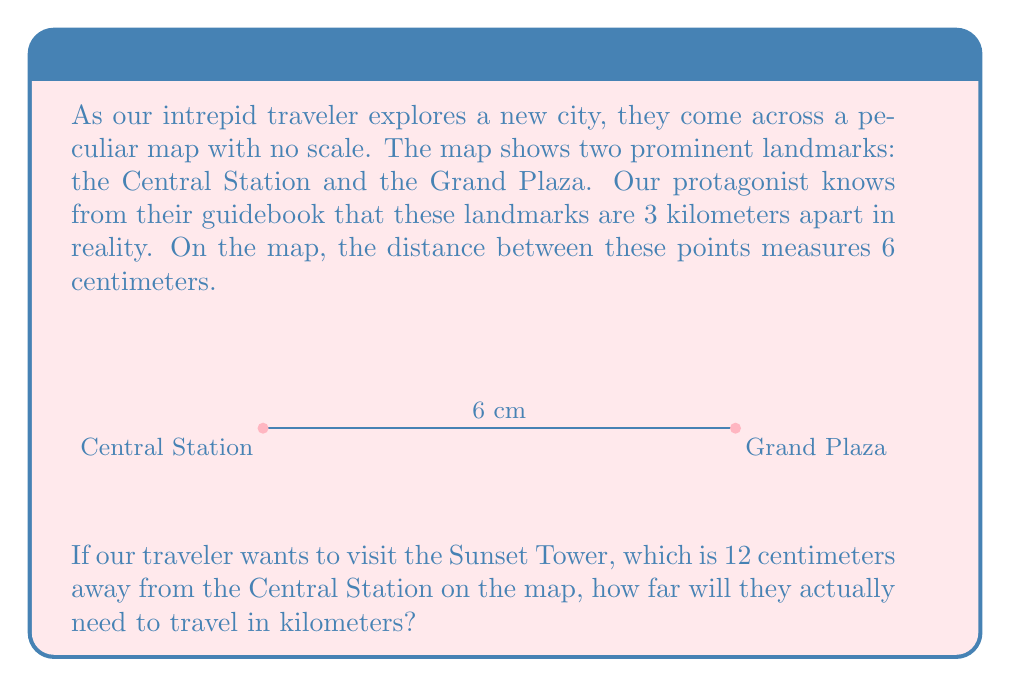Show me your answer to this math problem. Let's approach this step-by-step:

1) First, we need to determine the scale of the map. We know that:
   - The actual distance between landmarks is 3 km
   - The distance on the map is 6 cm

2) To find the scale, we set up the following equation:
   $$ \frac{6 \text{ cm on map}}{3 \text{ km in reality}} = \frac{1 \text{ cm on map}}{x \text{ km in reality}} $$

3) Cross-multiply:
   $$ 6x = 3 $$

4) Solve for x:
   $$ x = \frac{3}{6} = 0.5 $$

5) This means that 1 cm on the map represents 0.5 km in reality.

6) Now, we know the Sunset Tower is 12 cm away on the map. To find the real distance:
   $$ 12 \text{ cm} \times 0.5 \frac{\text{km}}{\text{cm}} = 6 \text{ km} $$

Therefore, our traveler will need to travel 6 km to reach the Sunset Tower.
Answer: 6 km 